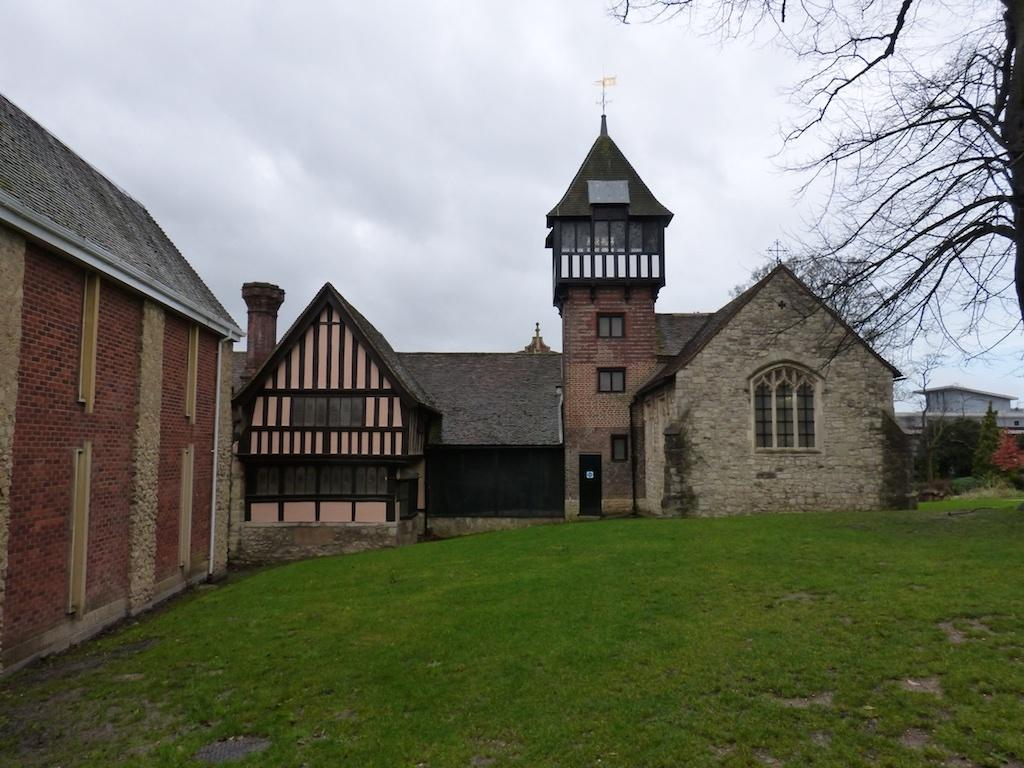What type of structures can be seen in the image? There are houses in the image. What type of vegetation is present in the image? There are trees and grass in the image. What is visible at the top of the image? The sky is visible at the top of the image. How many members are on the team in the image? There is no team present in the image. What type of rock can be seen in the image? There is no rock present in the image. 